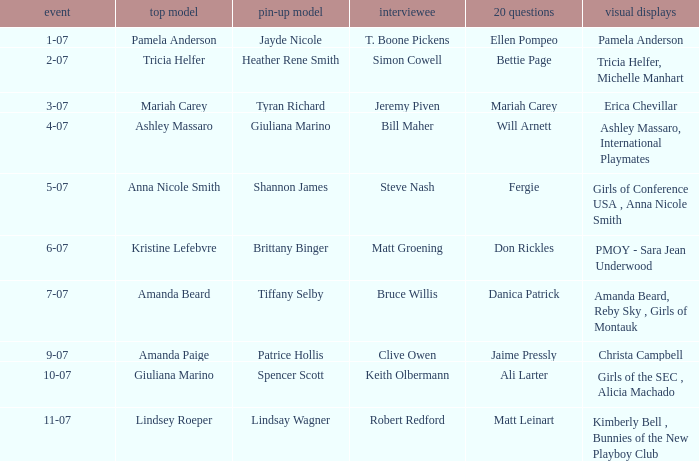Who was the centerfold model when the issue's pictorial was amanda beard, reby sky , girls of montauk ? Tiffany Selby. 